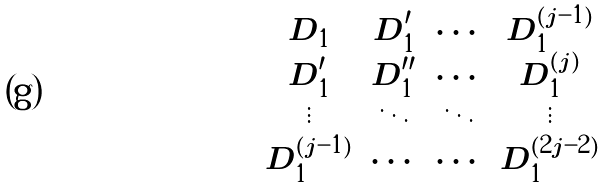<formula> <loc_0><loc_0><loc_500><loc_500>\begin{matrix} D _ { 1 } & D _ { 1 } ^ { \prime } & \cdots & D _ { 1 } ^ { ( j - 1 ) } \\ D _ { 1 } ^ { \prime } & D _ { 1 } ^ { \prime \prime } & \cdots & D _ { 1 } ^ { ( j ) } \\ \vdots & \ddots & \ddots & \vdots \\ D _ { 1 } ^ { ( j - 1 ) } & \cdots & \cdots & D _ { 1 } ^ { ( 2 j - 2 ) } \end{matrix}</formula> 